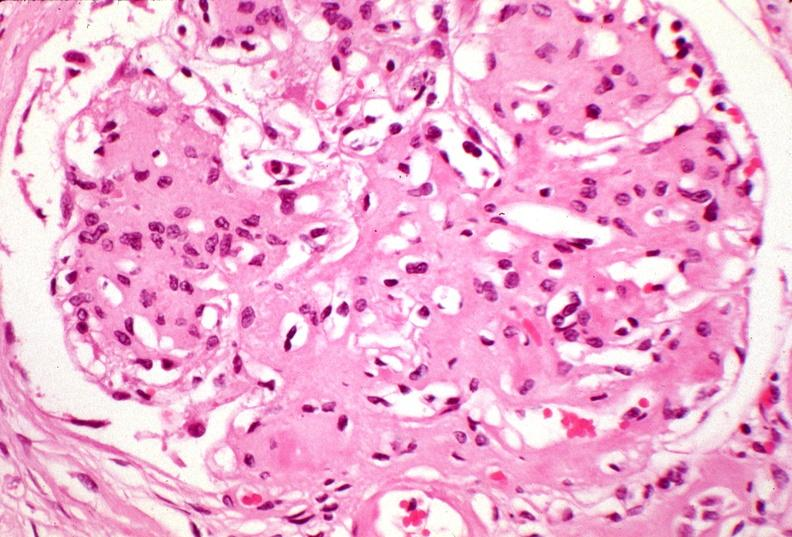does this image show kidney, kw kimmelstiel-wilson?
Answer the question using a single word or phrase. Yes 